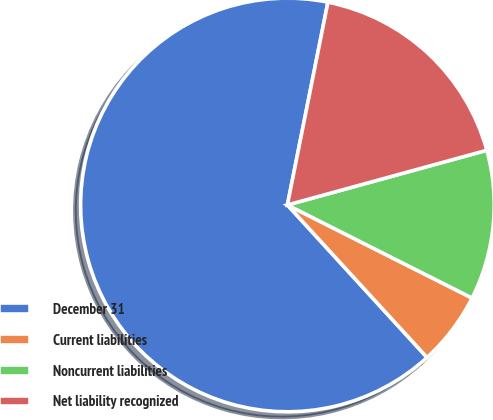<chart> <loc_0><loc_0><loc_500><loc_500><pie_chart><fcel>December 31<fcel>Current liabilities<fcel>Noncurrent liabilities<fcel>Net liability recognized<nl><fcel>64.94%<fcel>5.77%<fcel>11.69%<fcel>17.6%<nl></chart> 